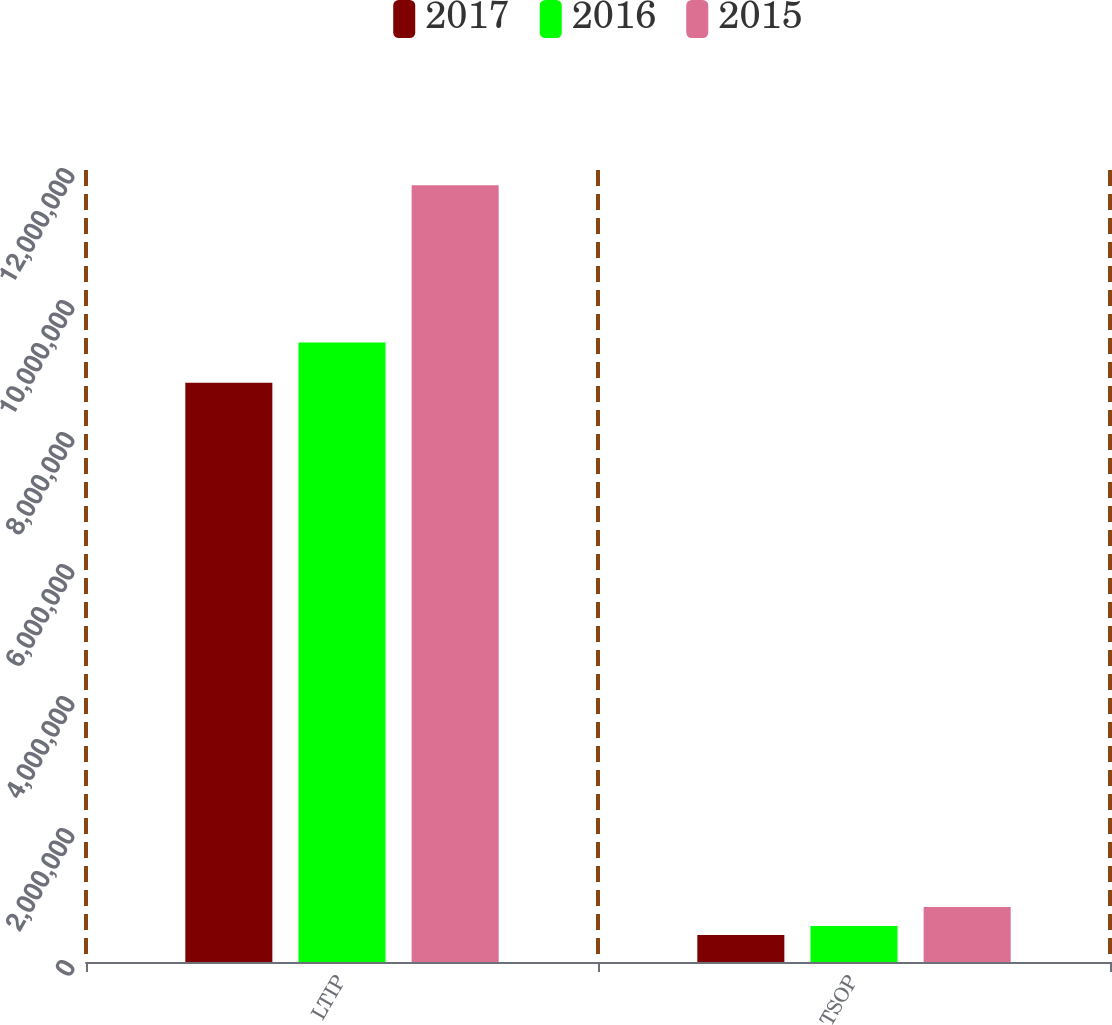Convert chart to OTSL. <chart><loc_0><loc_0><loc_500><loc_500><stacked_bar_chart><ecel><fcel>LTIP<fcel>TSOP<nl><fcel>2017<fcel>8.77477e+06<fcel>410895<nl><fcel>2016<fcel>9.38567e+06<fcel>544217<nl><fcel>2015<fcel>1.17698e+07<fcel>832676<nl></chart> 